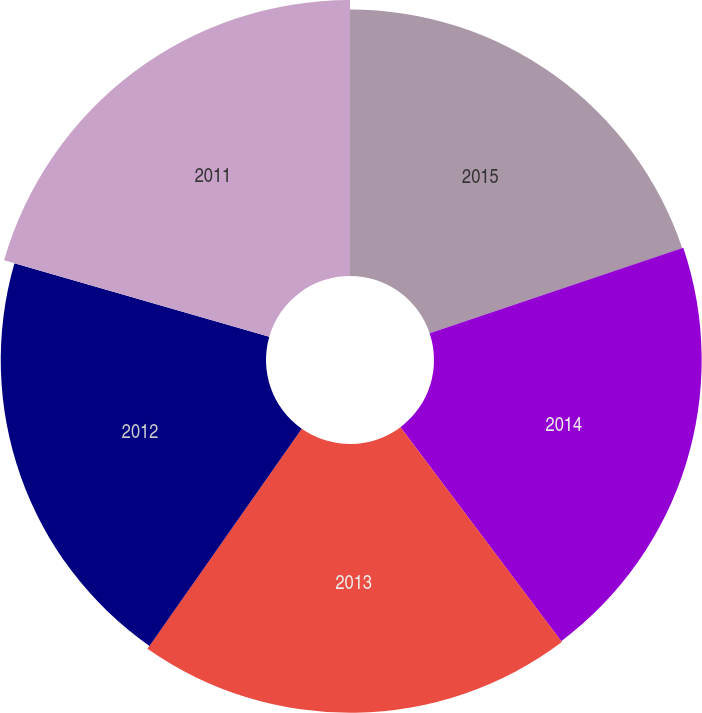Convert chart to OTSL. <chart><loc_0><loc_0><loc_500><loc_500><pie_chart><fcel>2015<fcel>2014<fcel>2013<fcel>2012<fcel>2011<nl><fcel>19.83%<fcel>19.91%<fcel>19.99%<fcel>19.73%<fcel>20.53%<nl></chart> 